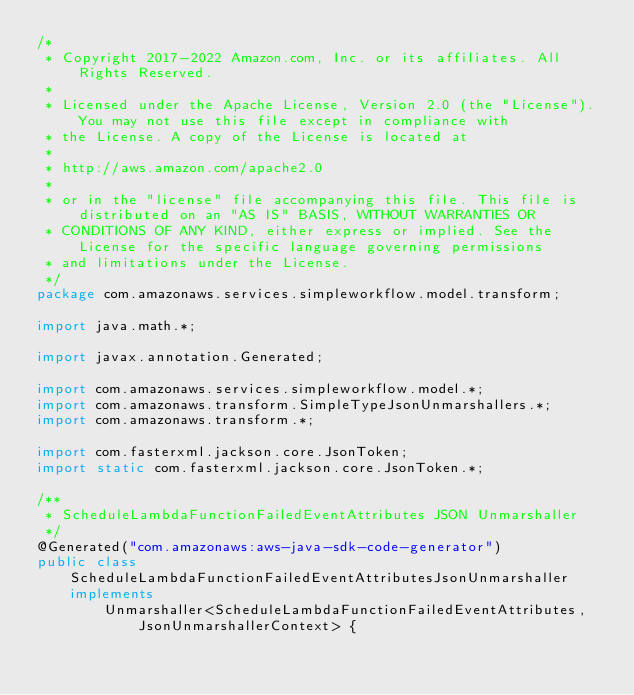Convert code to text. <code><loc_0><loc_0><loc_500><loc_500><_Java_>/*
 * Copyright 2017-2022 Amazon.com, Inc. or its affiliates. All Rights Reserved.
 * 
 * Licensed under the Apache License, Version 2.0 (the "License"). You may not use this file except in compliance with
 * the License. A copy of the License is located at
 * 
 * http://aws.amazon.com/apache2.0
 * 
 * or in the "license" file accompanying this file. This file is distributed on an "AS IS" BASIS, WITHOUT WARRANTIES OR
 * CONDITIONS OF ANY KIND, either express or implied. See the License for the specific language governing permissions
 * and limitations under the License.
 */
package com.amazonaws.services.simpleworkflow.model.transform;

import java.math.*;

import javax.annotation.Generated;

import com.amazonaws.services.simpleworkflow.model.*;
import com.amazonaws.transform.SimpleTypeJsonUnmarshallers.*;
import com.amazonaws.transform.*;

import com.fasterxml.jackson.core.JsonToken;
import static com.fasterxml.jackson.core.JsonToken.*;

/**
 * ScheduleLambdaFunctionFailedEventAttributes JSON Unmarshaller
 */
@Generated("com.amazonaws:aws-java-sdk-code-generator")
public class ScheduleLambdaFunctionFailedEventAttributesJsonUnmarshaller implements
        Unmarshaller<ScheduleLambdaFunctionFailedEventAttributes, JsonUnmarshallerContext> {
</code> 